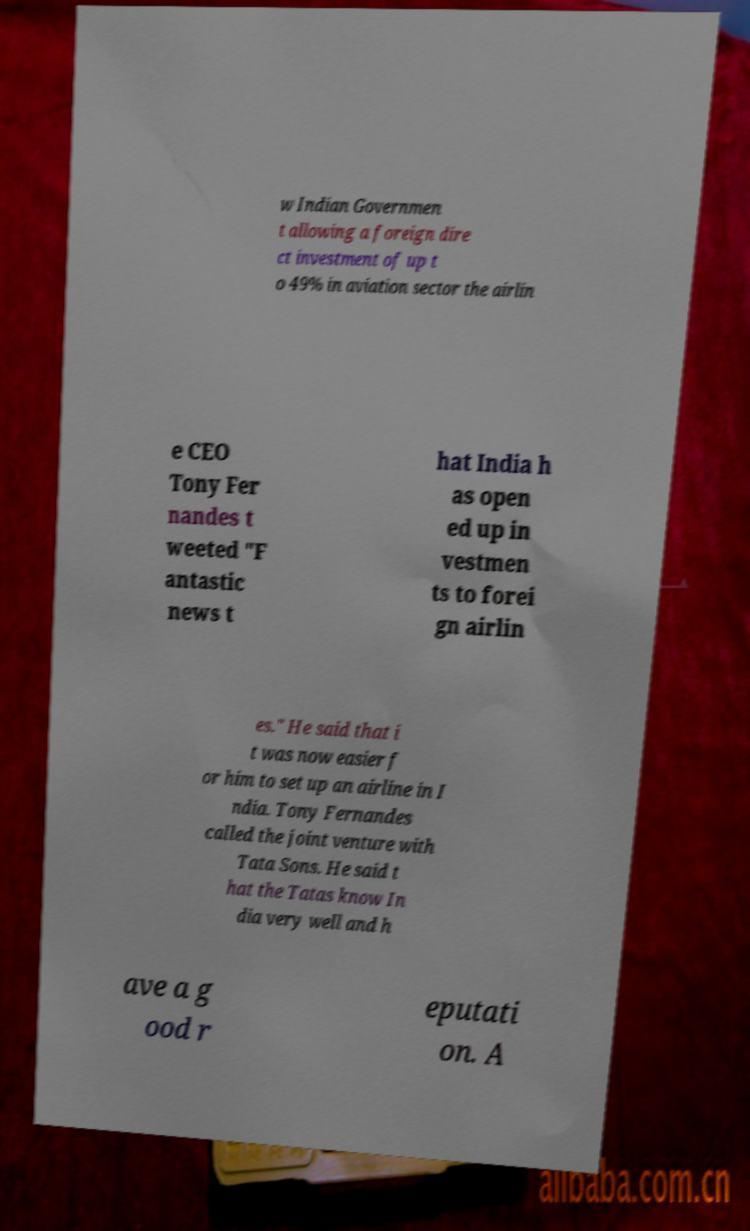I need the written content from this picture converted into text. Can you do that? w Indian Governmen t allowing a foreign dire ct investment of up t o 49% in aviation sector the airlin e CEO Tony Fer nandes t weeted "F antastic news t hat India h as open ed up in vestmen ts to forei gn airlin es." He said that i t was now easier f or him to set up an airline in I ndia. Tony Fernandes called the joint venture with Tata Sons. He said t hat the Tatas know In dia very well and h ave a g ood r eputati on. A 